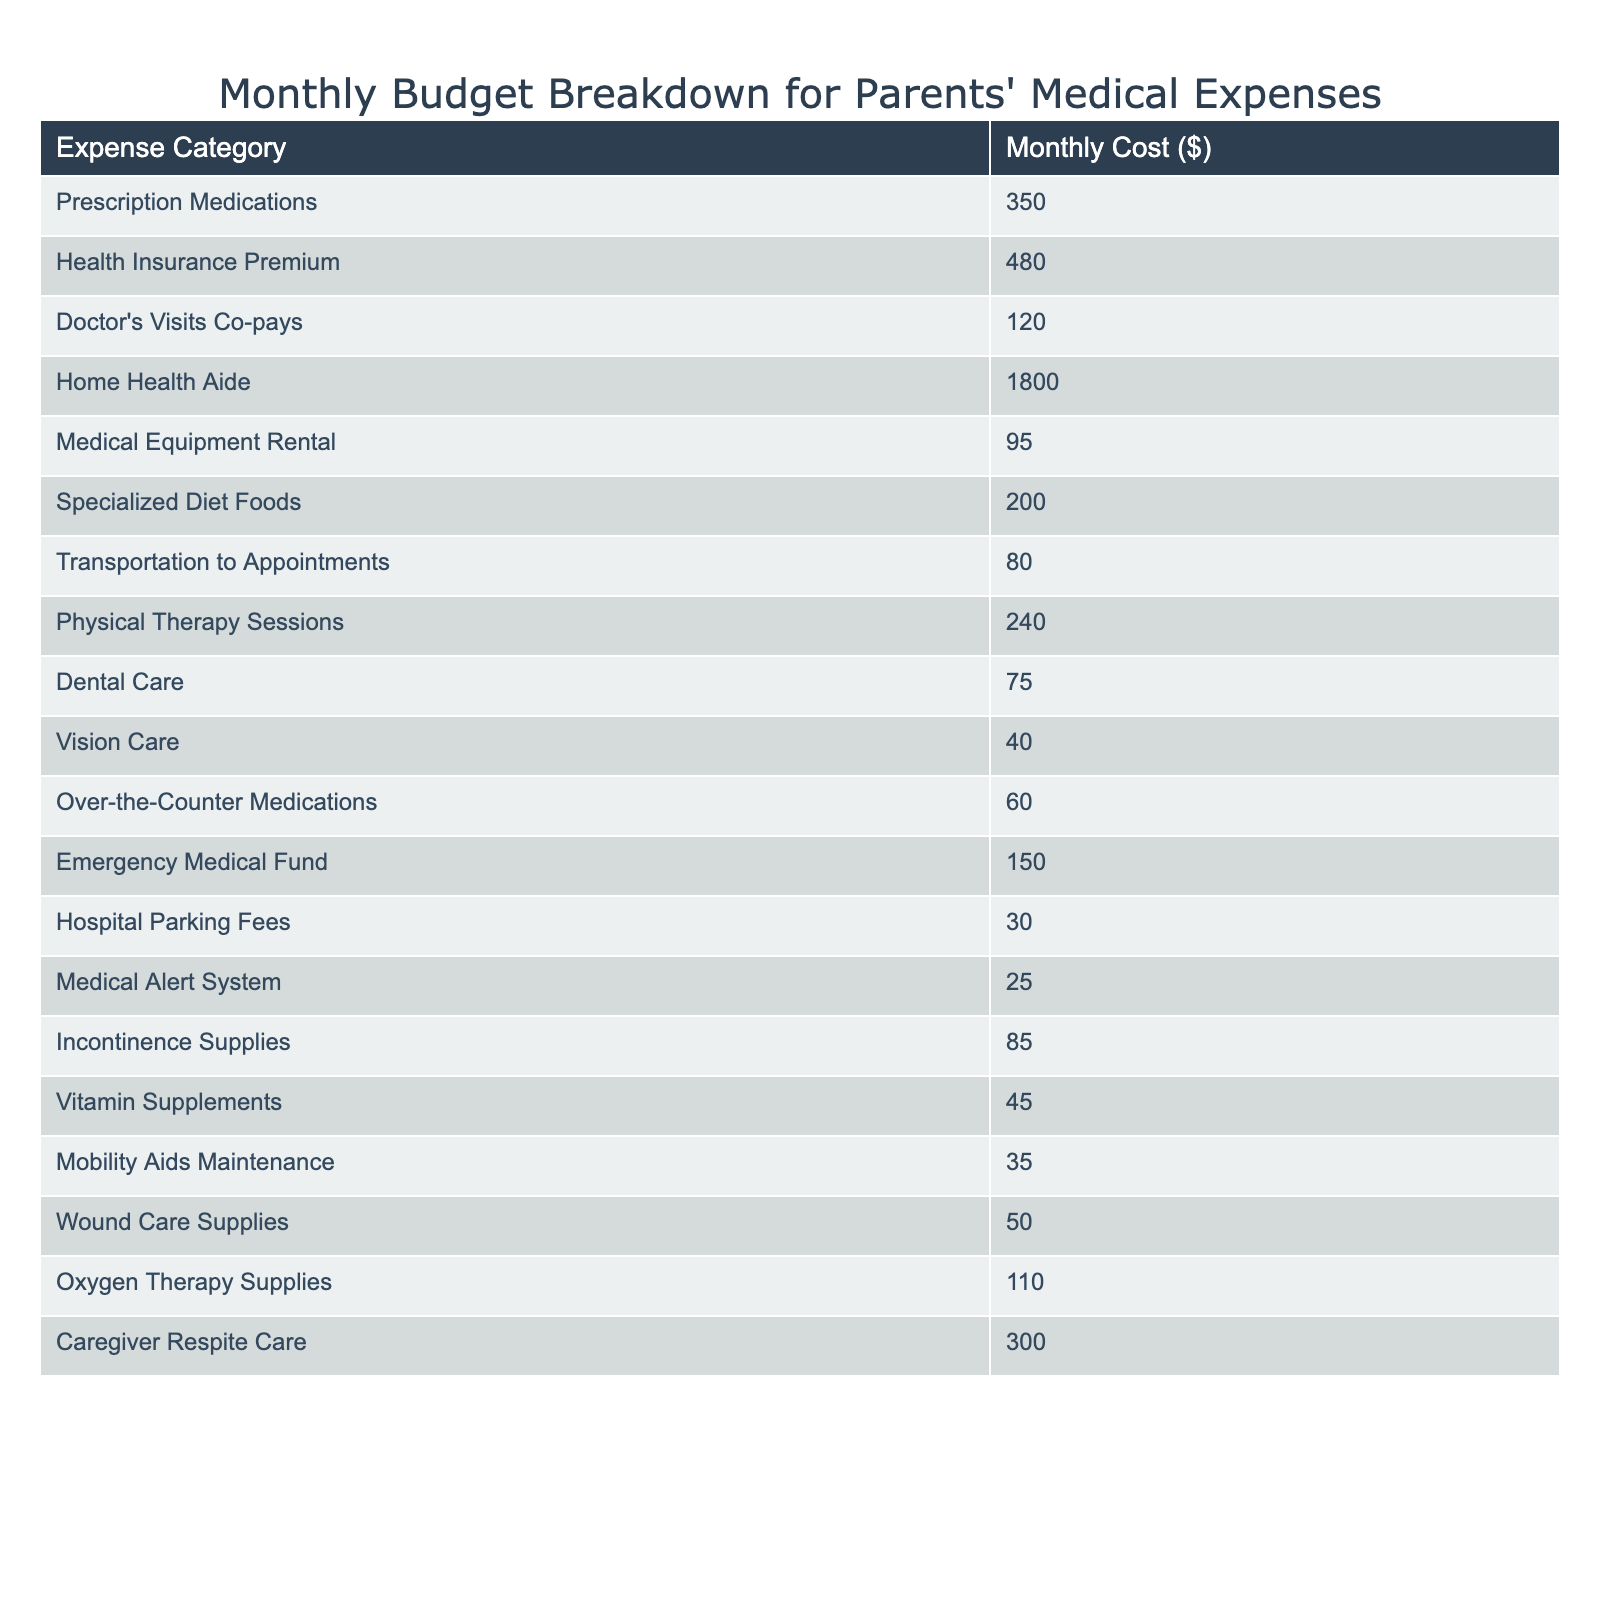What is the total monthly cost of prescription medications? The table shows the monthly cost for prescription medications is listed directly as $350.
Answer: 350 What are the monthly costs associated with transportation to appointments and dental care combined? The costs for transportation to appointments is $80 and for dental care is $75. Adding these amounts gives $80 + $75 = $155.
Answer: 155 How much does the home health aide service cost monthly? The table indicates that the monthly cost for home health aide services is $1,800.
Answer: 1800 Is the cost of the emergency medical fund greater than the cost for vision care? The emergency medical fund costs $150 while vision care costs $40. Since $150 is greater than $40, the answer is yes.
Answer: Yes What is the total monthly cost for specialized diet foods and mobility aids maintenance? The monthly cost for specialized diet foods is $200 and for mobility aids maintenance is $35. Adding these amounts gives $200 + $35 = $235.
Answer: 235 What is the average cost of medical equipment rental and oxygen therapy supplies? The cost for medical equipment rental is $95 and for oxygen therapy supplies is $110. To find the average, add the two costs: $95 + $110 = $205, then divide by 2 giving $205 / 2 = $102.5.
Answer: 102.5 How much less does the cost of dental care compare to the total of emergency medical fund and hospital parking fees? Dental care costs $75. The total for emergency medical fund and hospital parking fees is $150 + $30 = $180. The difference is $180 - $75 = $105.
Answer: 105 Which expense category has the highest monthly cost? Reviewing the table, home health aide has the highest cost at $1,800 compared to all other categories.
Answer: Home Health Aide What is the total monthly expenditure for all the healthcare-related items listed? To find the total, sum all the individual costs: $350 + $480 + $120 + $1800 + $95 + $200 + $80 + $240 + $75 + $40 + $60 + $150 + $30 + $25 + $85 + $45 + $35 + $50 + $110 + $300 = $3,985.
Answer: 3985 How does the cost of over-the-counter medications compare to the combined total of vision care and hospital parking fees? The cost of over-the-counter medications is $60. The combined total for vision care ($40) and hospital parking fees ($30) is $40 + $30 = $70. Since $60 is less than $70, the answer is no.
Answer: No 